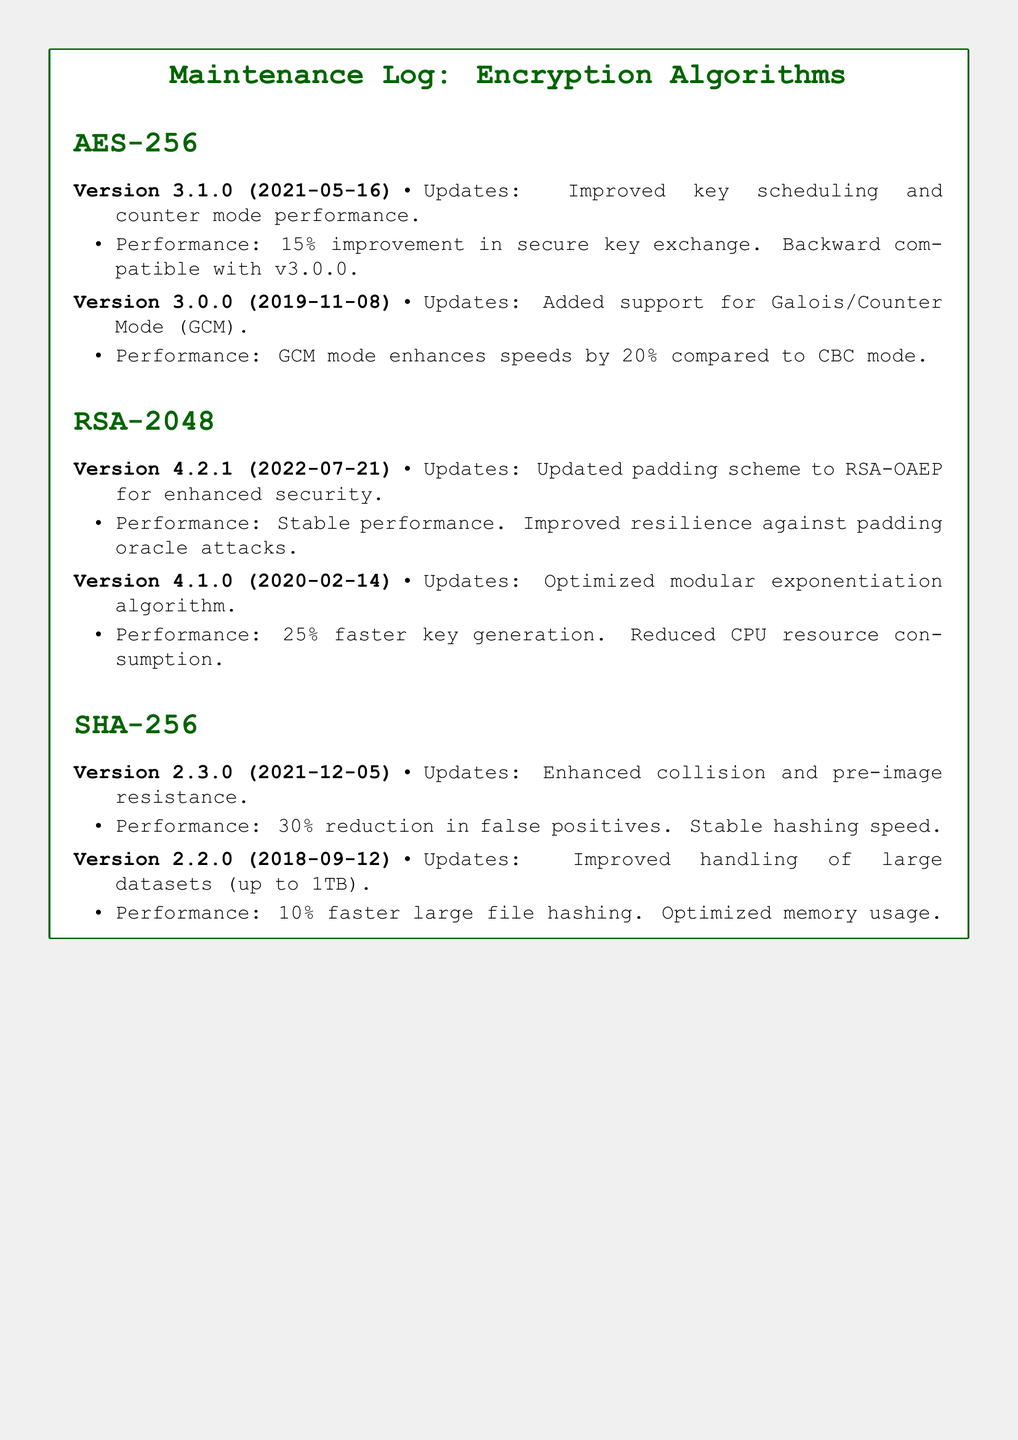What is the latest version of AES-256? The latest version of AES-256 mentioned in the document is 3.1.0, which was released on 2021-05-16.
Answer: 3.1.0 What is the performance improvement in secure key exchange for version 3.1.0 of AES-256? The performance improvement in secure key exchange for version 3.1.0 is 15%.
Answer: 15% What update was added in version 4.2.1 of RSA-2048? Version 4.2.1 of RSA-2048 has updated the padding scheme to RSA-OAEP for enhanced security.
Answer: RSA-OAEP What was the speed enhancement achieved by Galois/Counter Mode in AES-256? Galois/Counter Mode in AES-256 enhances speeds by 20% compared to CBC mode.
Answer: 20% What is the performance improvement for SHA-256 in version 2.3.0? The performance improvement for SHA-256 in version 2.3.0 includes a 30% reduction in false positives and stable hashing speed.
Answer: 30% What is the release date of version 4.1.0 of RSA-2048? The release date of version 4.1.0 of RSA-2048 is 2020-02-14.
Answer: 2020-02-14 Which encryption algorithm improved large file handling in version 2.2.0? The encryption algorithm that improved large file handling in version 2.2.0 is SHA-256.
Answer: SHA-256 How much faster is key generation in version 4.1.0 of RSA-2048 compared to its previous version? Version 4.1.0 of RSA-2048 achieved a 25% faster key generation than its previous version.
Answer: 25% What is the overall theme of the document? The overall theme of the document focuses on the maintenance log for encryption algorithms, including version history, updates, and performance notes.
Answer: Maintenance log for encryption algorithms 